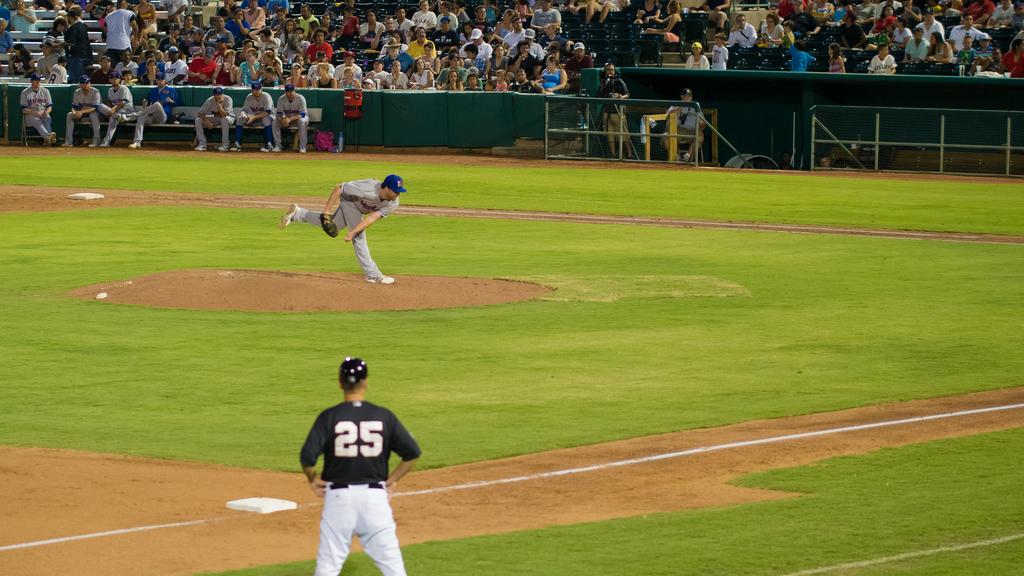What is the number on the kids white jersey with his back to the crowd, he is standing behind the last player on the bench?
Your answer should be compact. 8. 